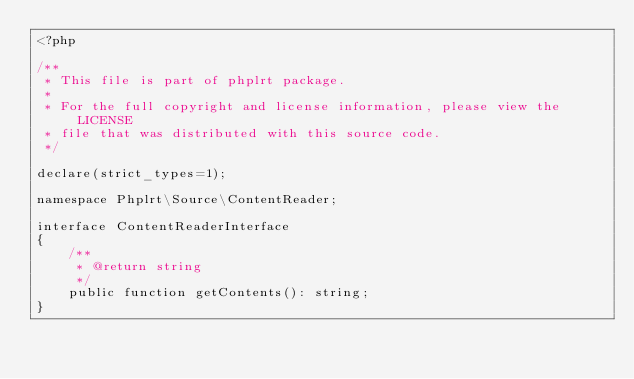Convert code to text. <code><loc_0><loc_0><loc_500><loc_500><_PHP_><?php

/**
 * This file is part of phplrt package.
 *
 * For the full copyright and license information, please view the LICENSE
 * file that was distributed with this source code.
 */

declare(strict_types=1);

namespace Phplrt\Source\ContentReader;

interface ContentReaderInterface
{
    /**
     * @return string
     */
    public function getContents(): string;
}
</code> 